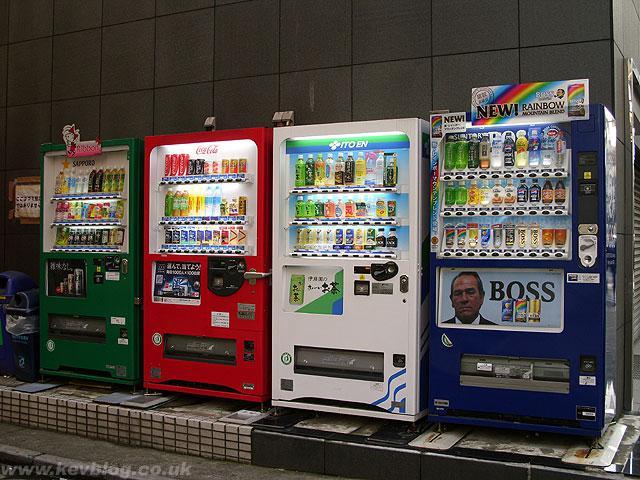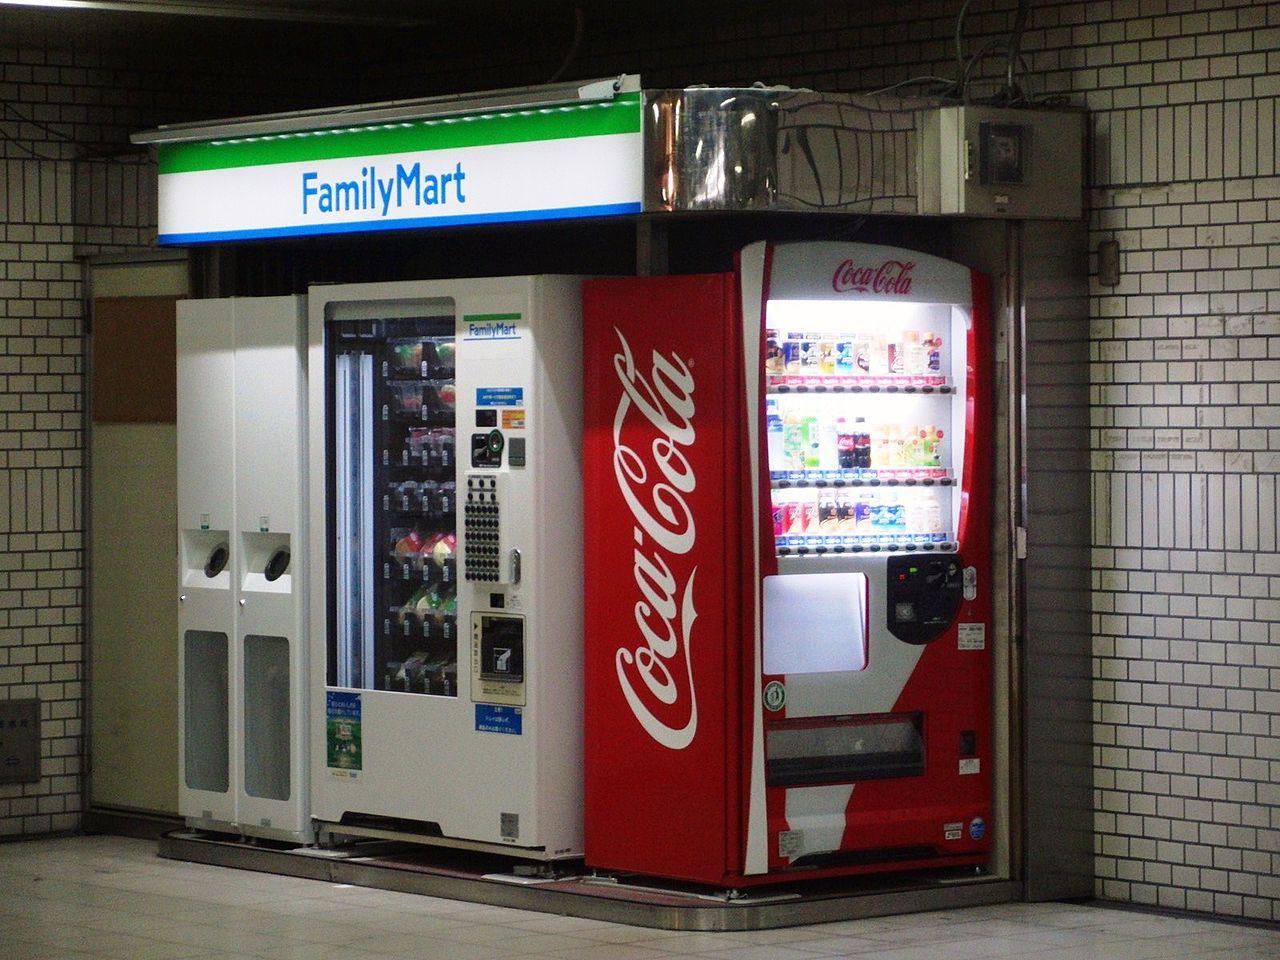The first image is the image on the left, the second image is the image on the right. Analyze the images presented: Is the assertion "There is exactly one vending machine in the image on the left." valid? Answer yes or no. No. 